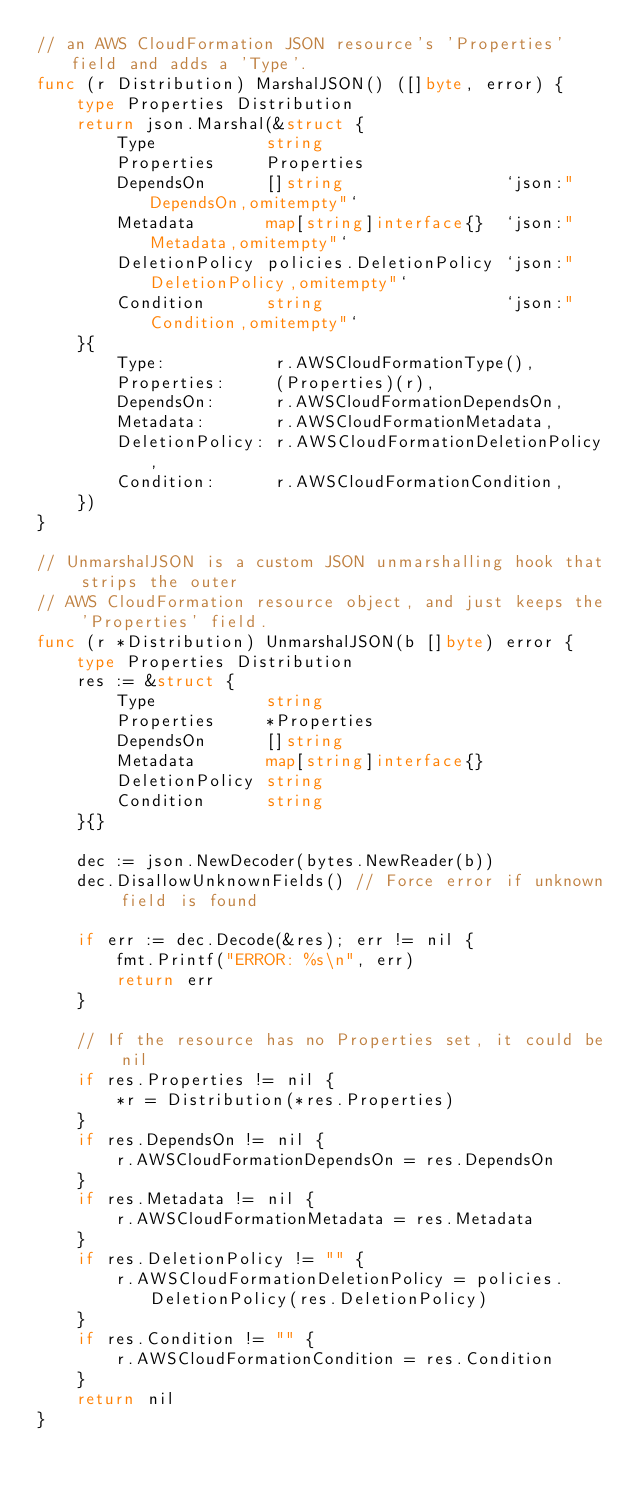Convert code to text. <code><loc_0><loc_0><loc_500><loc_500><_Go_>// an AWS CloudFormation JSON resource's 'Properties' field and adds a 'Type'.
func (r Distribution) MarshalJSON() ([]byte, error) {
	type Properties Distribution
	return json.Marshal(&struct {
		Type           string
		Properties     Properties
		DependsOn      []string                `json:"DependsOn,omitempty"`
		Metadata       map[string]interface{}  `json:"Metadata,omitempty"`
		DeletionPolicy policies.DeletionPolicy `json:"DeletionPolicy,omitempty"`
		Condition      string                  `json:"Condition,omitempty"`
	}{
		Type:           r.AWSCloudFormationType(),
		Properties:     (Properties)(r),
		DependsOn:      r.AWSCloudFormationDependsOn,
		Metadata:       r.AWSCloudFormationMetadata,
		DeletionPolicy: r.AWSCloudFormationDeletionPolicy,
		Condition:      r.AWSCloudFormationCondition,
	})
}

// UnmarshalJSON is a custom JSON unmarshalling hook that strips the outer
// AWS CloudFormation resource object, and just keeps the 'Properties' field.
func (r *Distribution) UnmarshalJSON(b []byte) error {
	type Properties Distribution
	res := &struct {
		Type           string
		Properties     *Properties
		DependsOn      []string
		Metadata       map[string]interface{}
		DeletionPolicy string
		Condition      string
	}{}

	dec := json.NewDecoder(bytes.NewReader(b))
	dec.DisallowUnknownFields() // Force error if unknown field is found

	if err := dec.Decode(&res); err != nil {
		fmt.Printf("ERROR: %s\n", err)
		return err
	}

	// If the resource has no Properties set, it could be nil
	if res.Properties != nil {
		*r = Distribution(*res.Properties)
	}
	if res.DependsOn != nil {
		r.AWSCloudFormationDependsOn = res.DependsOn
	}
	if res.Metadata != nil {
		r.AWSCloudFormationMetadata = res.Metadata
	}
	if res.DeletionPolicy != "" {
		r.AWSCloudFormationDeletionPolicy = policies.DeletionPolicy(res.DeletionPolicy)
	}
	if res.Condition != "" {
		r.AWSCloudFormationCondition = res.Condition
	}
	return nil
}
</code> 